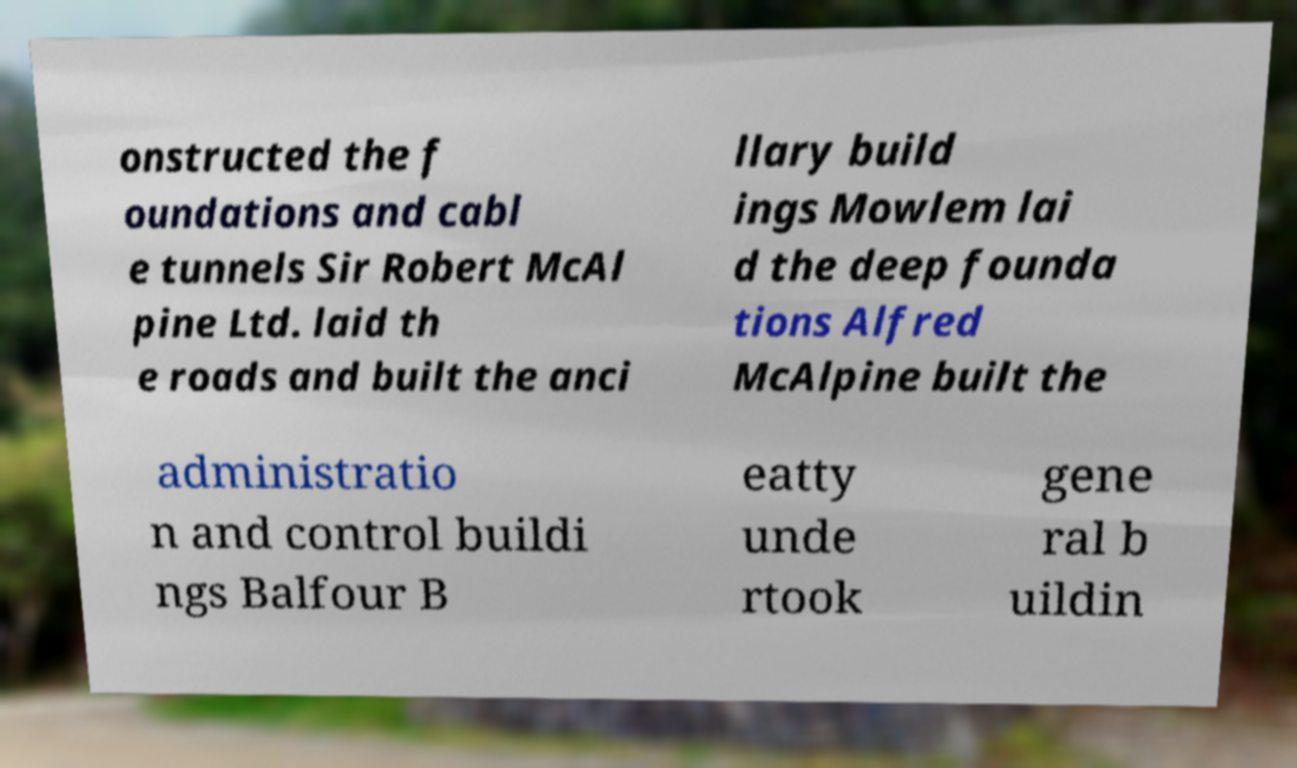Can you read and provide the text displayed in the image?This photo seems to have some interesting text. Can you extract and type it out for me? onstructed the f oundations and cabl e tunnels Sir Robert McAl pine Ltd. laid th e roads and built the anci llary build ings Mowlem lai d the deep founda tions Alfred McAlpine built the administratio n and control buildi ngs Balfour B eatty unde rtook gene ral b uildin 